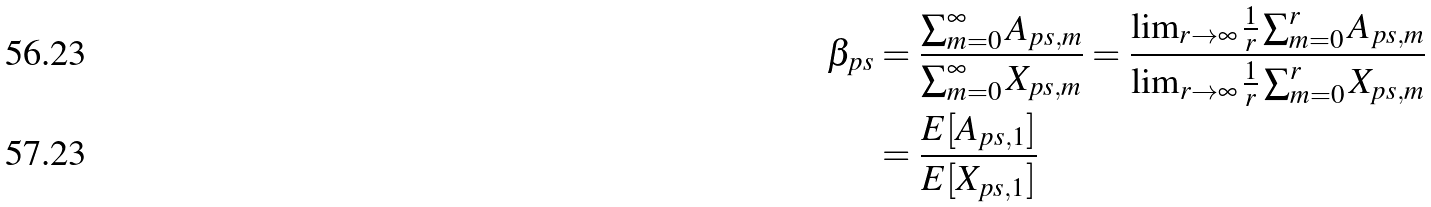Convert formula to latex. <formula><loc_0><loc_0><loc_500><loc_500>\beta _ { p s } & = \frac { \sum _ { m = 0 } ^ { \infty } A _ { p s , m } } { \sum _ { m = 0 } ^ { \infty } X _ { p s , m } } = \frac { \lim _ { r \to \infty } \frac { 1 } { r } \sum _ { m = 0 } ^ { r } A _ { p s , m } } { \lim _ { r \to \infty } \frac { 1 } { r } \sum _ { m = 0 } ^ { r } X _ { p s , m } } \\ & = \frac { E [ A _ { p s , 1 } ] } { E [ X _ { p s , 1 } ] }</formula> 